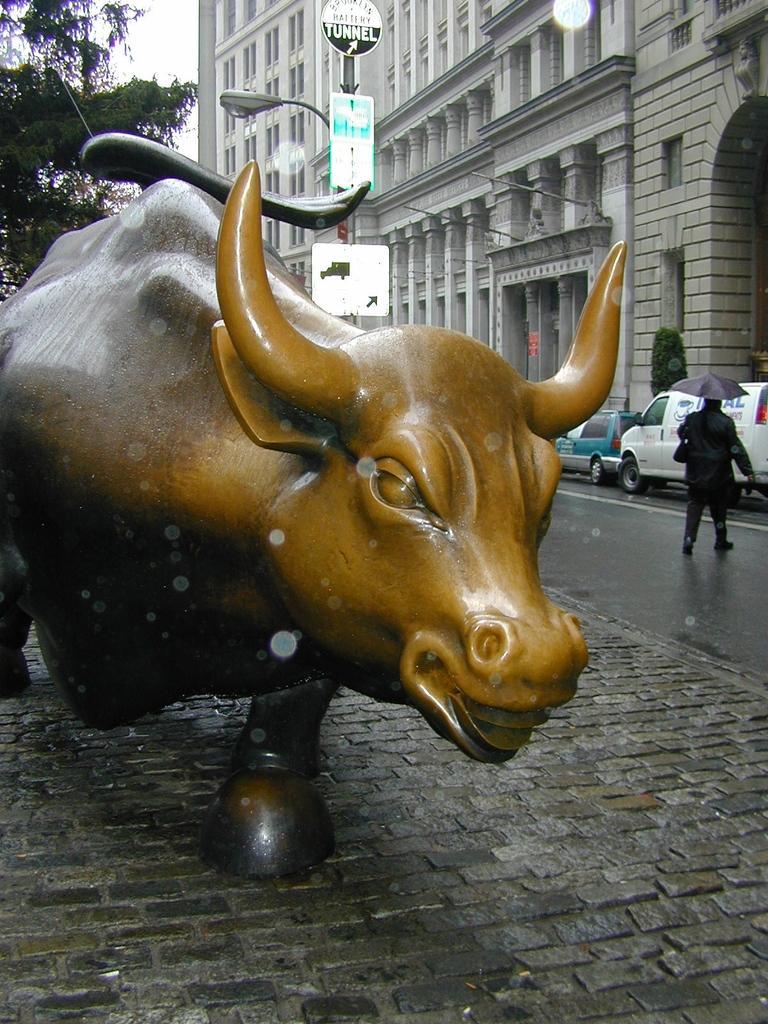Please provide a concise description of this image. In this image, we can see a statue on the path. On the right side, a person is crossing a road. Here we can see umbrella, vehicles, plant, boards, poles and street light. Background we can see walls, pillars, tree and sky. 